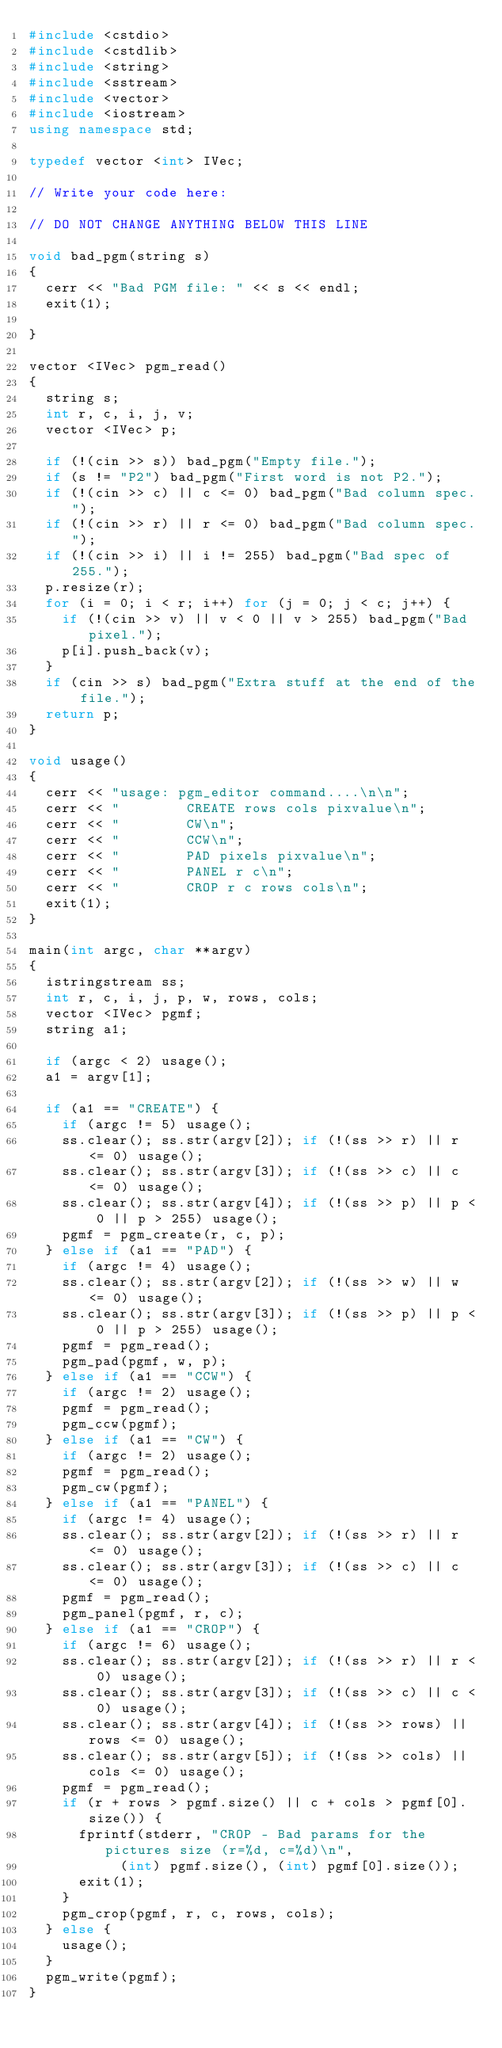<code> <loc_0><loc_0><loc_500><loc_500><_C++_>#include <cstdio>
#include <cstdlib>
#include <string>
#include <sstream>
#include <vector>
#include <iostream>
using namespace std;

typedef vector <int> IVec;

// Write your code here:

// DO NOT CHANGE ANYTHING BELOW THIS LINE

void bad_pgm(string s)
{
  cerr << "Bad PGM file: " << s << endl;
  exit(1);

}

vector <IVec> pgm_read()
{
  string s;
  int r, c, i, j, v;
  vector <IVec> p;

  if (!(cin >> s)) bad_pgm("Empty file.");
  if (s != "P2") bad_pgm("First word is not P2.");
  if (!(cin >> c) || c <= 0) bad_pgm("Bad column spec.");
  if (!(cin >> r) || r <= 0) bad_pgm("Bad column spec.");
  if (!(cin >> i) || i != 255) bad_pgm("Bad spec of 255.");
  p.resize(r);
  for (i = 0; i < r; i++) for (j = 0; j < c; j++) {
    if (!(cin >> v) || v < 0 || v > 255) bad_pgm("Bad pixel.");
    p[i].push_back(v);
  }
  if (cin >> s) bad_pgm("Extra stuff at the end of the file.");
  return p;
}

void usage()
{
  cerr << "usage: pgm_editor command....\n\n";
  cerr << "        CREATE rows cols pixvalue\n";
  cerr << "        CW\n";
  cerr << "        CCW\n";
  cerr << "        PAD pixels pixvalue\n";
  cerr << "        PANEL r c\n";
  cerr << "        CROP r c rows cols\n";
  exit(1);
}

main(int argc, char **argv)
{
  istringstream ss;
  int r, c, i, j, p, w, rows, cols;
  vector <IVec> pgmf;
  string a1;

  if (argc < 2) usage();
  a1 = argv[1];

  if (a1 == "CREATE") {
    if (argc != 5) usage();
    ss.clear(); ss.str(argv[2]); if (!(ss >> r) || r <= 0) usage();
    ss.clear(); ss.str(argv[3]); if (!(ss >> c) || c <= 0) usage();
    ss.clear(); ss.str(argv[4]); if (!(ss >> p) || p < 0 || p > 255) usage();
    pgmf = pgm_create(r, c, p);
  } else if (a1 == "PAD") {
    if (argc != 4) usage();
    ss.clear(); ss.str(argv[2]); if (!(ss >> w) || w <= 0) usage();
    ss.clear(); ss.str(argv[3]); if (!(ss >> p) || p < 0 || p > 255) usage();
    pgmf = pgm_read();
    pgm_pad(pgmf, w, p);
  } else if (a1 == "CCW") {
    if (argc != 2) usage();
    pgmf = pgm_read();
    pgm_ccw(pgmf);
  } else if (a1 == "CW") {
    if (argc != 2) usage();
    pgmf = pgm_read();
    pgm_cw(pgmf);
  } else if (a1 == "PANEL") {
    if (argc != 4) usage();
    ss.clear(); ss.str(argv[2]); if (!(ss >> r) || r <= 0) usage();
    ss.clear(); ss.str(argv[3]); if (!(ss >> c) || c <= 0) usage();
    pgmf = pgm_read();
    pgm_panel(pgmf, r, c);
  } else if (a1 == "CROP") {
    if (argc != 6) usage();
    ss.clear(); ss.str(argv[2]); if (!(ss >> r) || r < 0) usage();
    ss.clear(); ss.str(argv[3]); if (!(ss >> c) || c < 0) usage();
    ss.clear(); ss.str(argv[4]); if (!(ss >> rows) || rows <= 0) usage();
    ss.clear(); ss.str(argv[5]); if (!(ss >> cols) || cols <= 0) usage();
    pgmf = pgm_read();
    if (r + rows > pgmf.size() || c + cols > pgmf[0].size()) {
      fprintf(stderr, "CROP - Bad params for the pictures size (r=%d, c=%d)\n",
           (int) pgmf.size(), (int) pgmf[0].size());
      exit(1);
    }
    pgm_crop(pgmf, r, c, rows, cols);
  } else {
    usage();
  }
  pgm_write(pgmf);
}
</code> 